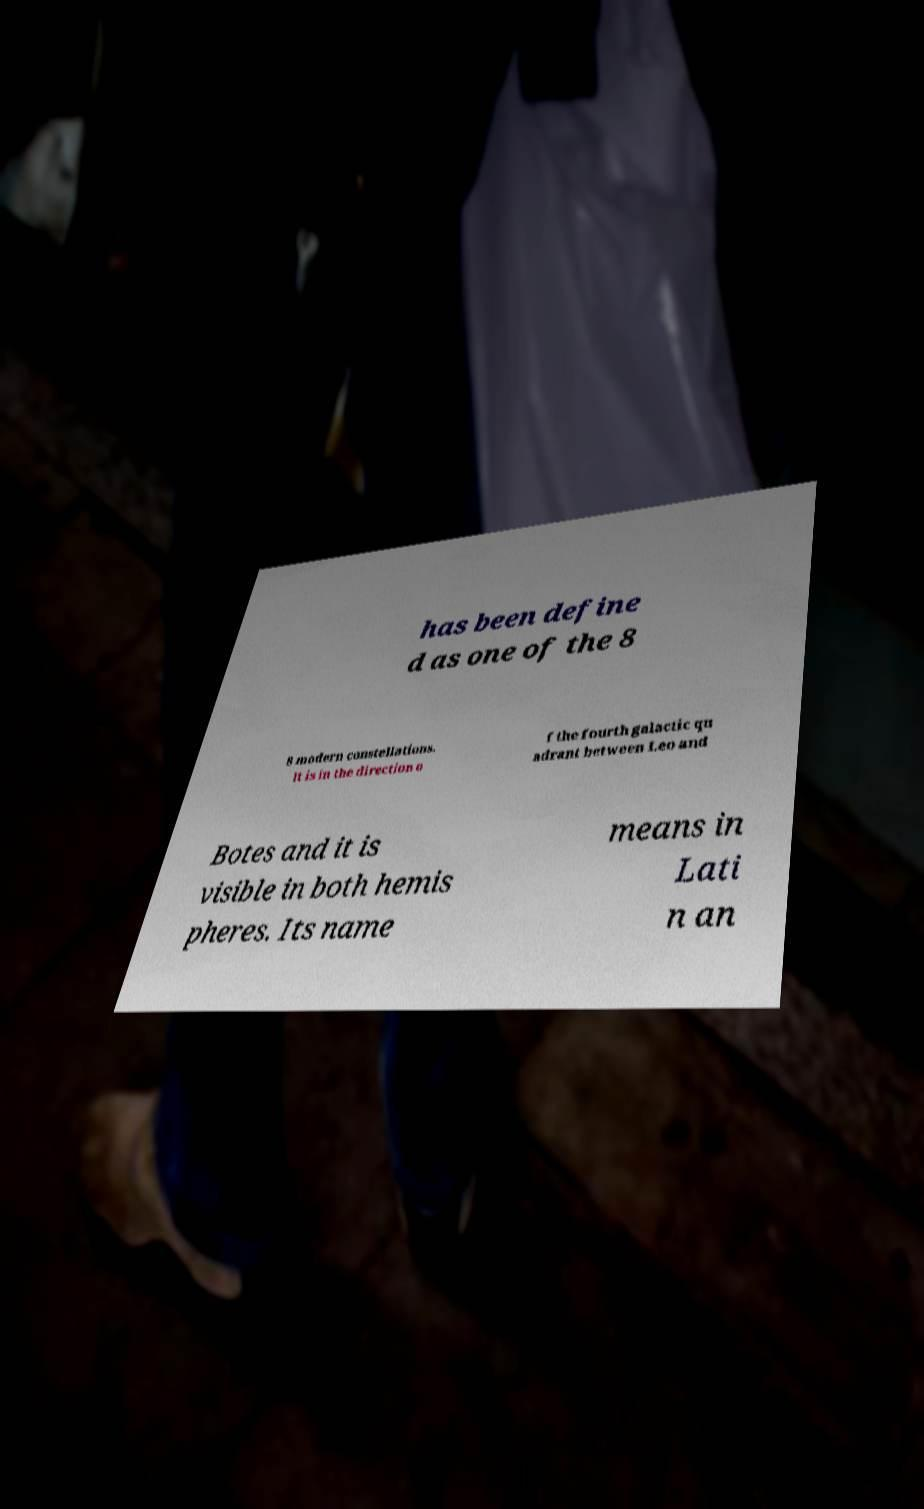Please read and relay the text visible in this image. What does it say? has been define d as one of the 8 8 modern constellations. It is in the direction o f the fourth galactic qu adrant between Leo and Botes and it is visible in both hemis pheres. Its name means in Lati n an 